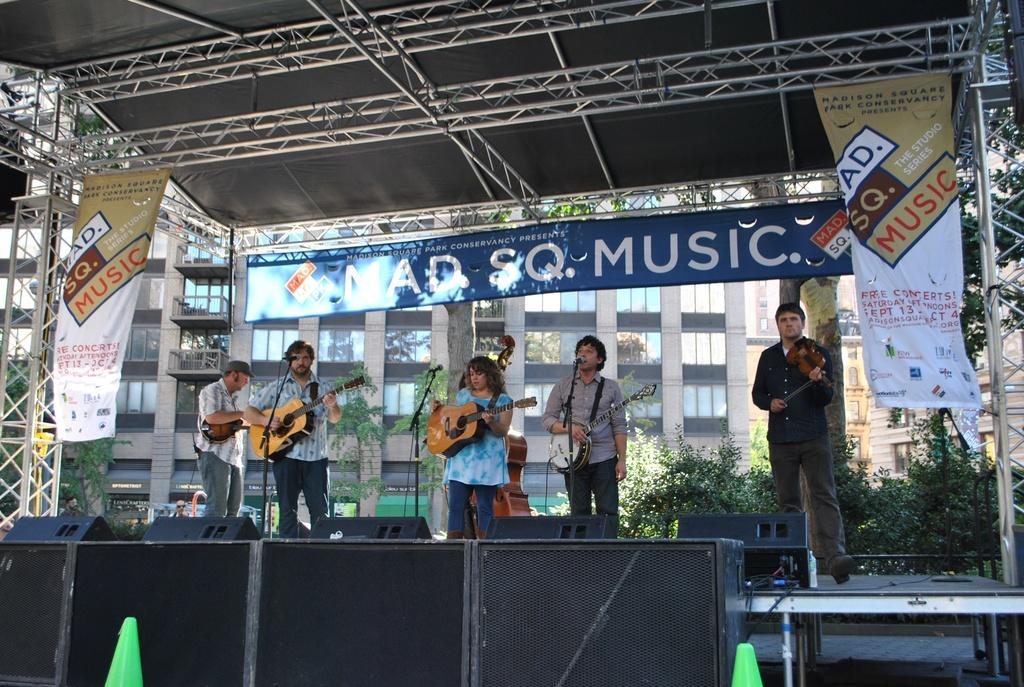What are the persons in the image doing? The persons in the image are playing musical instruments. What else can be seen in the image besides the persons playing instruments? There are banners, trees, a board, poles, and buildings in the image. What type of skirt is the tree wearing in the image? There are no trees wearing skirts in the image; trees are natural vegetation and do not wear clothing. 